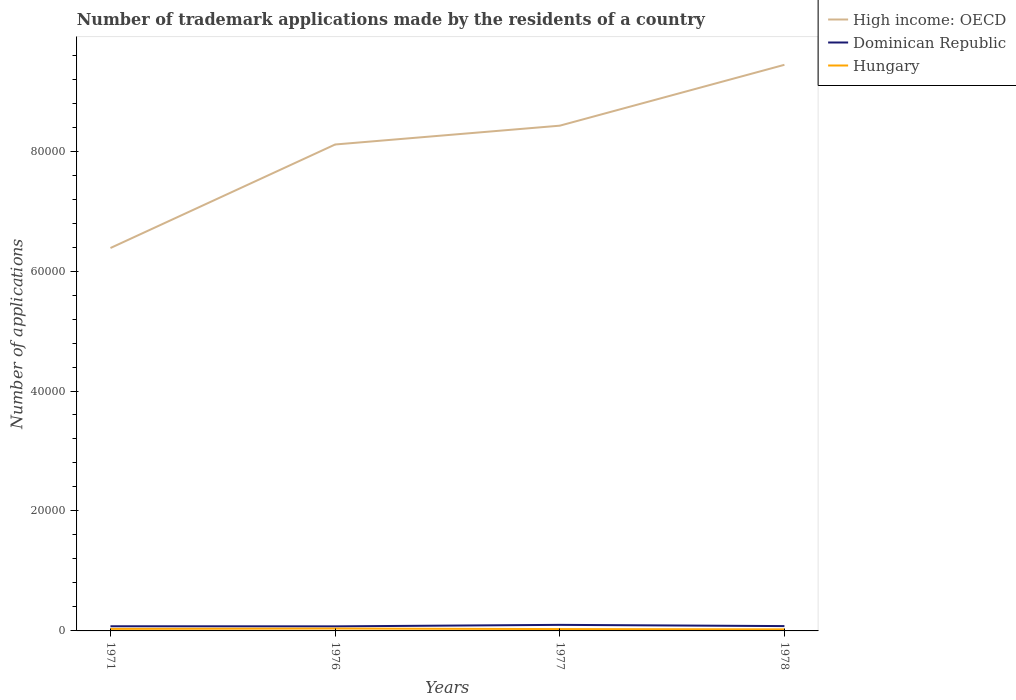Does the line corresponding to Dominican Republic intersect with the line corresponding to Hungary?
Make the answer very short. No. Across all years, what is the maximum number of trademark applications made by the residents in Hungary?
Your answer should be compact. 263. In which year was the number of trademark applications made by the residents in Hungary maximum?
Keep it short and to the point. 1978. What is the difference between the highest and the second highest number of trademark applications made by the residents in Hungary?
Keep it short and to the point. 130. What is the difference between two consecutive major ticks on the Y-axis?
Keep it short and to the point. 2.00e+04. Does the graph contain grids?
Provide a succinct answer. No. Where does the legend appear in the graph?
Provide a succinct answer. Top right. How many legend labels are there?
Your answer should be compact. 3. How are the legend labels stacked?
Offer a very short reply. Vertical. What is the title of the graph?
Offer a terse response. Number of trademark applications made by the residents of a country. Does "Romania" appear as one of the legend labels in the graph?
Your answer should be compact. No. What is the label or title of the Y-axis?
Offer a very short reply. Number of applications. What is the Number of applications of High income: OECD in 1971?
Make the answer very short. 6.38e+04. What is the Number of applications in Dominican Republic in 1971?
Offer a terse response. 775. What is the Number of applications in Hungary in 1971?
Your answer should be very brief. 336. What is the Number of applications in High income: OECD in 1976?
Your answer should be compact. 8.11e+04. What is the Number of applications in Dominican Republic in 1976?
Offer a very short reply. 761. What is the Number of applications of Hungary in 1976?
Your response must be concise. 393. What is the Number of applications of High income: OECD in 1977?
Your answer should be compact. 8.42e+04. What is the Number of applications of Dominican Republic in 1977?
Your response must be concise. 1010. What is the Number of applications of Hungary in 1977?
Provide a succinct answer. 310. What is the Number of applications in High income: OECD in 1978?
Your answer should be compact. 9.44e+04. What is the Number of applications in Dominican Republic in 1978?
Provide a succinct answer. 805. What is the Number of applications of Hungary in 1978?
Give a very brief answer. 263. Across all years, what is the maximum Number of applications of High income: OECD?
Your answer should be compact. 9.44e+04. Across all years, what is the maximum Number of applications of Dominican Republic?
Make the answer very short. 1010. Across all years, what is the maximum Number of applications of Hungary?
Offer a terse response. 393. Across all years, what is the minimum Number of applications in High income: OECD?
Keep it short and to the point. 6.38e+04. Across all years, what is the minimum Number of applications in Dominican Republic?
Offer a terse response. 761. Across all years, what is the minimum Number of applications of Hungary?
Your response must be concise. 263. What is the total Number of applications of High income: OECD in the graph?
Offer a terse response. 3.24e+05. What is the total Number of applications of Dominican Republic in the graph?
Offer a very short reply. 3351. What is the total Number of applications of Hungary in the graph?
Provide a succinct answer. 1302. What is the difference between the Number of applications in High income: OECD in 1971 and that in 1976?
Offer a very short reply. -1.73e+04. What is the difference between the Number of applications in Dominican Republic in 1971 and that in 1976?
Ensure brevity in your answer.  14. What is the difference between the Number of applications in Hungary in 1971 and that in 1976?
Your response must be concise. -57. What is the difference between the Number of applications in High income: OECD in 1971 and that in 1977?
Give a very brief answer. -2.04e+04. What is the difference between the Number of applications in Dominican Republic in 1971 and that in 1977?
Offer a terse response. -235. What is the difference between the Number of applications in Hungary in 1971 and that in 1977?
Make the answer very short. 26. What is the difference between the Number of applications of High income: OECD in 1971 and that in 1978?
Make the answer very short. -3.05e+04. What is the difference between the Number of applications of Hungary in 1971 and that in 1978?
Make the answer very short. 73. What is the difference between the Number of applications of High income: OECD in 1976 and that in 1977?
Provide a succinct answer. -3137. What is the difference between the Number of applications in Dominican Republic in 1976 and that in 1977?
Your answer should be very brief. -249. What is the difference between the Number of applications of Hungary in 1976 and that in 1977?
Provide a succinct answer. 83. What is the difference between the Number of applications of High income: OECD in 1976 and that in 1978?
Keep it short and to the point. -1.33e+04. What is the difference between the Number of applications in Dominican Republic in 1976 and that in 1978?
Offer a terse response. -44. What is the difference between the Number of applications in Hungary in 1976 and that in 1978?
Give a very brief answer. 130. What is the difference between the Number of applications of High income: OECD in 1977 and that in 1978?
Offer a very short reply. -1.02e+04. What is the difference between the Number of applications of Dominican Republic in 1977 and that in 1978?
Give a very brief answer. 205. What is the difference between the Number of applications of High income: OECD in 1971 and the Number of applications of Dominican Republic in 1976?
Offer a very short reply. 6.31e+04. What is the difference between the Number of applications in High income: OECD in 1971 and the Number of applications in Hungary in 1976?
Offer a terse response. 6.34e+04. What is the difference between the Number of applications of Dominican Republic in 1971 and the Number of applications of Hungary in 1976?
Your answer should be very brief. 382. What is the difference between the Number of applications in High income: OECD in 1971 and the Number of applications in Dominican Republic in 1977?
Give a very brief answer. 6.28e+04. What is the difference between the Number of applications of High income: OECD in 1971 and the Number of applications of Hungary in 1977?
Provide a succinct answer. 6.35e+04. What is the difference between the Number of applications of Dominican Republic in 1971 and the Number of applications of Hungary in 1977?
Make the answer very short. 465. What is the difference between the Number of applications of High income: OECD in 1971 and the Number of applications of Dominican Republic in 1978?
Your response must be concise. 6.30e+04. What is the difference between the Number of applications in High income: OECD in 1971 and the Number of applications in Hungary in 1978?
Provide a short and direct response. 6.36e+04. What is the difference between the Number of applications of Dominican Republic in 1971 and the Number of applications of Hungary in 1978?
Provide a succinct answer. 512. What is the difference between the Number of applications of High income: OECD in 1976 and the Number of applications of Dominican Republic in 1977?
Give a very brief answer. 8.01e+04. What is the difference between the Number of applications of High income: OECD in 1976 and the Number of applications of Hungary in 1977?
Provide a short and direct response. 8.08e+04. What is the difference between the Number of applications in Dominican Republic in 1976 and the Number of applications in Hungary in 1977?
Offer a terse response. 451. What is the difference between the Number of applications of High income: OECD in 1976 and the Number of applications of Dominican Republic in 1978?
Your answer should be compact. 8.03e+04. What is the difference between the Number of applications in High income: OECD in 1976 and the Number of applications in Hungary in 1978?
Provide a short and direct response. 8.08e+04. What is the difference between the Number of applications of Dominican Republic in 1976 and the Number of applications of Hungary in 1978?
Provide a short and direct response. 498. What is the difference between the Number of applications of High income: OECD in 1977 and the Number of applications of Dominican Republic in 1978?
Keep it short and to the point. 8.34e+04. What is the difference between the Number of applications in High income: OECD in 1977 and the Number of applications in Hungary in 1978?
Your response must be concise. 8.40e+04. What is the difference between the Number of applications of Dominican Republic in 1977 and the Number of applications of Hungary in 1978?
Offer a terse response. 747. What is the average Number of applications of High income: OECD per year?
Ensure brevity in your answer.  8.09e+04. What is the average Number of applications of Dominican Republic per year?
Your response must be concise. 837.75. What is the average Number of applications in Hungary per year?
Keep it short and to the point. 325.5. In the year 1971, what is the difference between the Number of applications of High income: OECD and Number of applications of Dominican Republic?
Offer a terse response. 6.31e+04. In the year 1971, what is the difference between the Number of applications in High income: OECD and Number of applications in Hungary?
Your answer should be compact. 6.35e+04. In the year 1971, what is the difference between the Number of applications of Dominican Republic and Number of applications of Hungary?
Ensure brevity in your answer.  439. In the year 1976, what is the difference between the Number of applications of High income: OECD and Number of applications of Dominican Republic?
Keep it short and to the point. 8.03e+04. In the year 1976, what is the difference between the Number of applications of High income: OECD and Number of applications of Hungary?
Your answer should be compact. 8.07e+04. In the year 1976, what is the difference between the Number of applications in Dominican Republic and Number of applications in Hungary?
Keep it short and to the point. 368. In the year 1977, what is the difference between the Number of applications in High income: OECD and Number of applications in Dominican Republic?
Keep it short and to the point. 8.32e+04. In the year 1977, what is the difference between the Number of applications in High income: OECD and Number of applications in Hungary?
Offer a terse response. 8.39e+04. In the year 1977, what is the difference between the Number of applications in Dominican Republic and Number of applications in Hungary?
Your answer should be very brief. 700. In the year 1978, what is the difference between the Number of applications in High income: OECD and Number of applications in Dominican Republic?
Your response must be concise. 9.36e+04. In the year 1978, what is the difference between the Number of applications in High income: OECD and Number of applications in Hungary?
Your answer should be compact. 9.41e+04. In the year 1978, what is the difference between the Number of applications of Dominican Republic and Number of applications of Hungary?
Make the answer very short. 542. What is the ratio of the Number of applications of High income: OECD in 1971 to that in 1976?
Give a very brief answer. 0.79. What is the ratio of the Number of applications of Dominican Republic in 1971 to that in 1976?
Your answer should be compact. 1.02. What is the ratio of the Number of applications in Hungary in 1971 to that in 1976?
Offer a very short reply. 0.85. What is the ratio of the Number of applications in High income: OECD in 1971 to that in 1977?
Your response must be concise. 0.76. What is the ratio of the Number of applications in Dominican Republic in 1971 to that in 1977?
Ensure brevity in your answer.  0.77. What is the ratio of the Number of applications in Hungary in 1971 to that in 1977?
Provide a succinct answer. 1.08. What is the ratio of the Number of applications of High income: OECD in 1971 to that in 1978?
Your answer should be compact. 0.68. What is the ratio of the Number of applications in Dominican Republic in 1971 to that in 1978?
Your response must be concise. 0.96. What is the ratio of the Number of applications in Hungary in 1971 to that in 1978?
Provide a succinct answer. 1.28. What is the ratio of the Number of applications in High income: OECD in 1976 to that in 1977?
Your response must be concise. 0.96. What is the ratio of the Number of applications in Dominican Republic in 1976 to that in 1977?
Make the answer very short. 0.75. What is the ratio of the Number of applications in Hungary in 1976 to that in 1977?
Offer a terse response. 1.27. What is the ratio of the Number of applications in High income: OECD in 1976 to that in 1978?
Provide a succinct answer. 0.86. What is the ratio of the Number of applications of Dominican Republic in 1976 to that in 1978?
Give a very brief answer. 0.95. What is the ratio of the Number of applications in Hungary in 1976 to that in 1978?
Your answer should be very brief. 1.49. What is the ratio of the Number of applications in High income: OECD in 1977 to that in 1978?
Your answer should be compact. 0.89. What is the ratio of the Number of applications of Dominican Republic in 1977 to that in 1978?
Provide a succinct answer. 1.25. What is the ratio of the Number of applications in Hungary in 1977 to that in 1978?
Give a very brief answer. 1.18. What is the difference between the highest and the second highest Number of applications in High income: OECD?
Make the answer very short. 1.02e+04. What is the difference between the highest and the second highest Number of applications in Dominican Republic?
Keep it short and to the point. 205. What is the difference between the highest and the lowest Number of applications of High income: OECD?
Provide a succinct answer. 3.05e+04. What is the difference between the highest and the lowest Number of applications of Dominican Republic?
Provide a succinct answer. 249. What is the difference between the highest and the lowest Number of applications in Hungary?
Keep it short and to the point. 130. 